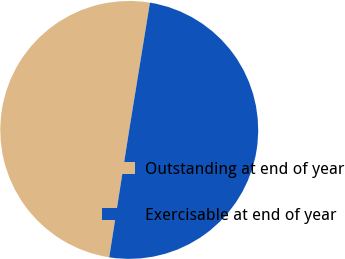<chart> <loc_0><loc_0><loc_500><loc_500><pie_chart><fcel>Outstanding at end of year<fcel>Exercisable at end of year<nl><fcel>50.09%<fcel>49.91%<nl></chart> 